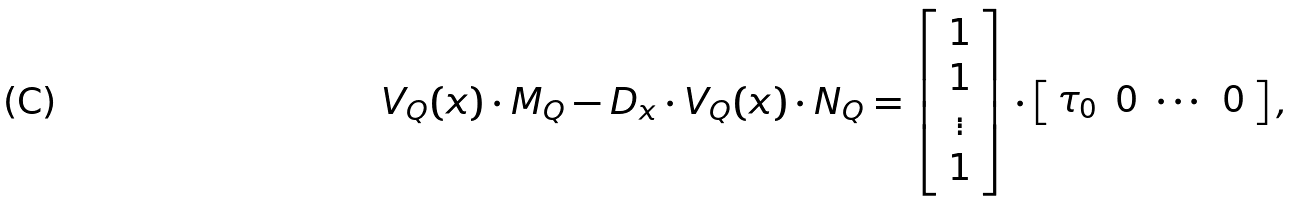Convert formula to latex. <formula><loc_0><loc_0><loc_500><loc_500>V _ { Q } ( x ) \cdot M _ { Q } - D _ { x } \cdot V _ { Q } ( x ) \cdot N _ { Q } = \left [ \begin{array} { c } 1 \\ 1 \\ \vdots \\ 1 \\ \end{array} \right ] \cdot \left [ \begin{array} { c c c c } \tau _ { 0 } & 0 & \cdots & 0 \end{array} \right ] ,</formula> 